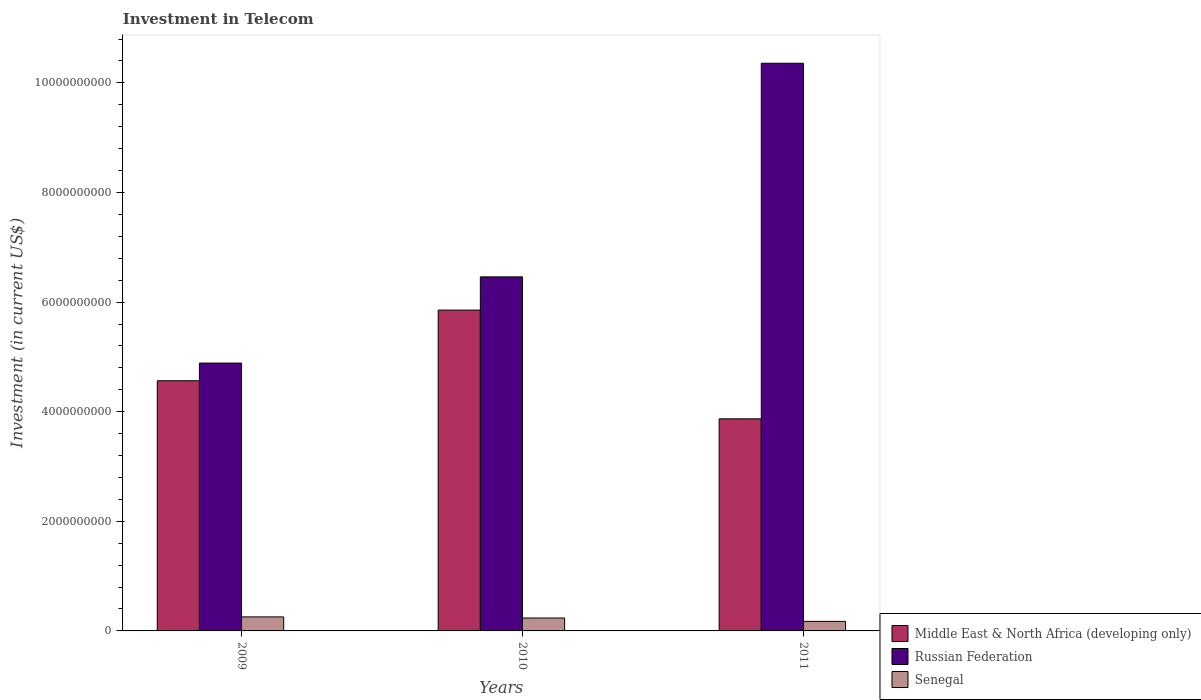How many groups of bars are there?
Your response must be concise. 3. Are the number of bars on each tick of the X-axis equal?
Give a very brief answer. Yes. How many bars are there on the 3rd tick from the left?
Your answer should be very brief. 3. What is the label of the 2nd group of bars from the left?
Provide a short and direct response. 2010. In how many cases, is the number of bars for a given year not equal to the number of legend labels?
Give a very brief answer. 0. What is the amount invested in telecom in Russian Federation in 2010?
Make the answer very short. 6.46e+09. Across all years, what is the maximum amount invested in telecom in Senegal?
Provide a short and direct response. 2.56e+08. Across all years, what is the minimum amount invested in telecom in Senegal?
Provide a short and direct response. 1.74e+08. In which year was the amount invested in telecom in Senegal maximum?
Your answer should be compact. 2009. What is the total amount invested in telecom in Senegal in the graph?
Give a very brief answer. 6.66e+08. What is the difference between the amount invested in telecom in Middle East & North Africa (developing only) in 2009 and that in 2010?
Ensure brevity in your answer.  -1.29e+09. What is the difference between the amount invested in telecom in Senegal in 2010 and the amount invested in telecom in Middle East & North Africa (developing only) in 2009?
Provide a short and direct response. -4.33e+09. What is the average amount invested in telecom in Russian Federation per year?
Offer a very short reply. 7.24e+09. In the year 2010, what is the difference between the amount invested in telecom in Senegal and amount invested in telecom in Russian Federation?
Your answer should be compact. -6.22e+09. What is the ratio of the amount invested in telecom in Senegal in 2009 to that in 2010?
Your answer should be compact. 1.08. What is the difference between the highest and the second highest amount invested in telecom in Middle East & North Africa (developing only)?
Your answer should be very brief. 1.29e+09. What is the difference between the highest and the lowest amount invested in telecom in Middle East & North Africa (developing only)?
Keep it short and to the point. 1.98e+09. In how many years, is the amount invested in telecom in Russian Federation greater than the average amount invested in telecom in Russian Federation taken over all years?
Keep it short and to the point. 1. Is the sum of the amount invested in telecom in Middle East & North Africa (developing only) in 2010 and 2011 greater than the maximum amount invested in telecom in Senegal across all years?
Give a very brief answer. Yes. What does the 2nd bar from the left in 2009 represents?
Your answer should be compact. Russian Federation. What does the 1st bar from the right in 2009 represents?
Offer a very short reply. Senegal. Is it the case that in every year, the sum of the amount invested in telecom in Russian Federation and amount invested in telecom in Senegal is greater than the amount invested in telecom in Middle East & North Africa (developing only)?
Ensure brevity in your answer.  Yes. Are all the bars in the graph horizontal?
Provide a short and direct response. No. How many years are there in the graph?
Offer a terse response. 3. What is the difference between two consecutive major ticks on the Y-axis?
Provide a short and direct response. 2.00e+09. Are the values on the major ticks of Y-axis written in scientific E-notation?
Keep it short and to the point. No. Does the graph contain grids?
Provide a succinct answer. No. What is the title of the graph?
Provide a succinct answer. Investment in Telecom. Does "San Marino" appear as one of the legend labels in the graph?
Offer a very short reply. No. What is the label or title of the Y-axis?
Give a very brief answer. Investment (in current US$). What is the Investment (in current US$) in Middle East & North Africa (developing only) in 2009?
Your answer should be compact. 4.56e+09. What is the Investment (in current US$) in Russian Federation in 2009?
Make the answer very short. 4.89e+09. What is the Investment (in current US$) in Senegal in 2009?
Give a very brief answer. 2.56e+08. What is the Investment (in current US$) of Middle East & North Africa (developing only) in 2010?
Provide a succinct answer. 5.85e+09. What is the Investment (in current US$) of Russian Federation in 2010?
Offer a very short reply. 6.46e+09. What is the Investment (in current US$) in Senegal in 2010?
Make the answer very short. 2.36e+08. What is the Investment (in current US$) of Middle East & North Africa (developing only) in 2011?
Offer a terse response. 3.87e+09. What is the Investment (in current US$) of Russian Federation in 2011?
Offer a terse response. 1.04e+1. What is the Investment (in current US$) of Senegal in 2011?
Provide a succinct answer. 1.74e+08. Across all years, what is the maximum Investment (in current US$) in Middle East & North Africa (developing only)?
Provide a succinct answer. 5.85e+09. Across all years, what is the maximum Investment (in current US$) of Russian Federation?
Offer a very short reply. 1.04e+1. Across all years, what is the maximum Investment (in current US$) in Senegal?
Your response must be concise. 2.56e+08. Across all years, what is the minimum Investment (in current US$) in Middle East & North Africa (developing only)?
Keep it short and to the point. 3.87e+09. Across all years, what is the minimum Investment (in current US$) in Russian Federation?
Your answer should be compact. 4.89e+09. Across all years, what is the minimum Investment (in current US$) in Senegal?
Provide a short and direct response. 1.74e+08. What is the total Investment (in current US$) of Middle East & North Africa (developing only) in the graph?
Keep it short and to the point. 1.43e+1. What is the total Investment (in current US$) of Russian Federation in the graph?
Offer a very short reply. 2.17e+1. What is the total Investment (in current US$) in Senegal in the graph?
Ensure brevity in your answer.  6.66e+08. What is the difference between the Investment (in current US$) in Middle East & North Africa (developing only) in 2009 and that in 2010?
Provide a short and direct response. -1.29e+09. What is the difference between the Investment (in current US$) in Russian Federation in 2009 and that in 2010?
Provide a succinct answer. -1.57e+09. What is the difference between the Investment (in current US$) of Senegal in 2009 and that in 2010?
Give a very brief answer. 2.00e+07. What is the difference between the Investment (in current US$) of Middle East & North Africa (developing only) in 2009 and that in 2011?
Offer a very short reply. 6.95e+08. What is the difference between the Investment (in current US$) in Russian Federation in 2009 and that in 2011?
Give a very brief answer. -5.47e+09. What is the difference between the Investment (in current US$) in Senegal in 2009 and that in 2011?
Offer a terse response. 8.20e+07. What is the difference between the Investment (in current US$) in Middle East & North Africa (developing only) in 2010 and that in 2011?
Offer a very short reply. 1.98e+09. What is the difference between the Investment (in current US$) of Russian Federation in 2010 and that in 2011?
Offer a very short reply. -3.90e+09. What is the difference between the Investment (in current US$) of Senegal in 2010 and that in 2011?
Make the answer very short. 6.20e+07. What is the difference between the Investment (in current US$) of Middle East & North Africa (developing only) in 2009 and the Investment (in current US$) of Russian Federation in 2010?
Provide a short and direct response. -1.90e+09. What is the difference between the Investment (in current US$) of Middle East & North Africa (developing only) in 2009 and the Investment (in current US$) of Senegal in 2010?
Provide a succinct answer. 4.33e+09. What is the difference between the Investment (in current US$) in Russian Federation in 2009 and the Investment (in current US$) in Senegal in 2010?
Your answer should be very brief. 4.65e+09. What is the difference between the Investment (in current US$) in Middle East & North Africa (developing only) in 2009 and the Investment (in current US$) in Russian Federation in 2011?
Ensure brevity in your answer.  -5.79e+09. What is the difference between the Investment (in current US$) in Middle East & North Africa (developing only) in 2009 and the Investment (in current US$) in Senegal in 2011?
Your answer should be compact. 4.39e+09. What is the difference between the Investment (in current US$) in Russian Federation in 2009 and the Investment (in current US$) in Senegal in 2011?
Your answer should be very brief. 4.71e+09. What is the difference between the Investment (in current US$) in Middle East & North Africa (developing only) in 2010 and the Investment (in current US$) in Russian Federation in 2011?
Provide a short and direct response. -4.50e+09. What is the difference between the Investment (in current US$) of Middle East & North Africa (developing only) in 2010 and the Investment (in current US$) of Senegal in 2011?
Make the answer very short. 5.68e+09. What is the difference between the Investment (in current US$) in Russian Federation in 2010 and the Investment (in current US$) in Senegal in 2011?
Your answer should be very brief. 6.29e+09. What is the average Investment (in current US$) in Middle East & North Africa (developing only) per year?
Offer a very short reply. 4.76e+09. What is the average Investment (in current US$) in Russian Federation per year?
Offer a very short reply. 7.24e+09. What is the average Investment (in current US$) of Senegal per year?
Give a very brief answer. 2.22e+08. In the year 2009, what is the difference between the Investment (in current US$) of Middle East & North Africa (developing only) and Investment (in current US$) of Russian Federation?
Give a very brief answer. -3.22e+08. In the year 2009, what is the difference between the Investment (in current US$) of Middle East & North Africa (developing only) and Investment (in current US$) of Senegal?
Your answer should be compact. 4.31e+09. In the year 2009, what is the difference between the Investment (in current US$) in Russian Federation and Investment (in current US$) in Senegal?
Keep it short and to the point. 4.63e+09. In the year 2010, what is the difference between the Investment (in current US$) in Middle East & North Africa (developing only) and Investment (in current US$) in Russian Federation?
Your answer should be compact. -6.06e+08. In the year 2010, what is the difference between the Investment (in current US$) of Middle East & North Africa (developing only) and Investment (in current US$) of Senegal?
Offer a very short reply. 5.62e+09. In the year 2010, what is the difference between the Investment (in current US$) of Russian Federation and Investment (in current US$) of Senegal?
Your answer should be compact. 6.22e+09. In the year 2011, what is the difference between the Investment (in current US$) of Middle East & North Africa (developing only) and Investment (in current US$) of Russian Federation?
Your answer should be compact. -6.49e+09. In the year 2011, what is the difference between the Investment (in current US$) of Middle East & North Africa (developing only) and Investment (in current US$) of Senegal?
Give a very brief answer. 3.70e+09. In the year 2011, what is the difference between the Investment (in current US$) in Russian Federation and Investment (in current US$) in Senegal?
Offer a very short reply. 1.02e+1. What is the ratio of the Investment (in current US$) of Middle East & North Africa (developing only) in 2009 to that in 2010?
Offer a terse response. 0.78. What is the ratio of the Investment (in current US$) of Russian Federation in 2009 to that in 2010?
Make the answer very short. 0.76. What is the ratio of the Investment (in current US$) in Senegal in 2009 to that in 2010?
Your response must be concise. 1.08. What is the ratio of the Investment (in current US$) of Middle East & North Africa (developing only) in 2009 to that in 2011?
Give a very brief answer. 1.18. What is the ratio of the Investment (in current US$) of Russian Federation in 2009 to that in 2011?
Give a very brief answer. 0.47. What is the ratio of the Investment (in current US$) in Senegal in 2009 to that in 2011?
Offer a very short reply. 1.47. What is the ratio of the Investment (in current US$) of Middle East & North Africa (developing only) in 2010 to that in 2011?
Your answer should be compact. 1.51. What is the ratio of the Investment (in current US$) in Russian Federation in 2010 to that in 2011?
Offer a very short reply. 0.62. What is the ratio of the Investment (in current US$) of Senegal in 2010 to that in 2011?
Offer a very short reply. 1.36. What is the difference between the highest and the second highest Investment (in current US$) in Middle East & North Africa (developing only)?
Make the answer very short. 1.29e+09. What is the difference between the highest and the second highest Investment (in current US$) of Russian Federation?
Give a very brief answer. 3.90e+09. What is the difference between the highest and the lowest Investment (in current US$) of Middle East & North Africa (developing only)?
Provide a succinct answer. 1.98e+09. What is the difference between the highest and the lowest Investment (in current US$) of Russian Federation?
Provide a succinct answer. 5.47e+09. What is the difference between the highest and the lowest Investment (in current US$) in Senegal?
Make the answer very short. 8.20e+07. 